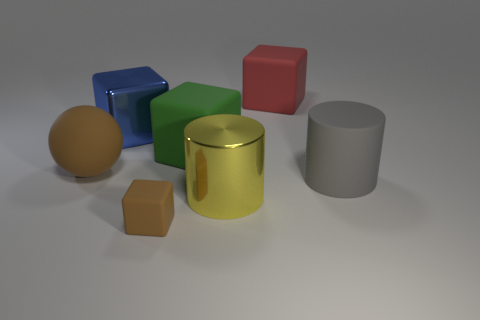Subtract 1 blocks. How many blocks are left? 3 Add 3 big brown spheres. How many objects exist? 10 Subtract all cubes. How many objects are left? 3 Subtract 0 blue balls. How many objects are left? 7 Subtract all tiny brown things. Subtract all big matte things. How many objects are left? 2 Add 7 big blue things. How many big blue things are left? 8 Add 5 tiny blue rubber spheres. How many tiny blue rubber spheres exist? 5 